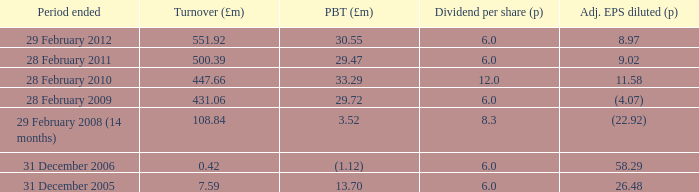How many items appear in the dividend per share when the turnover is 0.42? 1.0. 